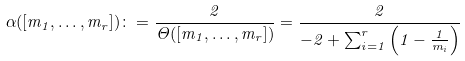Convert formula to latex. <formula><loc_0><loc_0><loc_500><loc_500>\alpha ( [ m _ { 1 } , \dots , m _ { r } ] ) \colon = \frac { 2 } { \Theta ( [ m _ { 1 } , \dots , m _ { r } ] ) } = \frac { 2 } { - 2 + \sum _ { i = 1 } ^ { r } \left ( 1 - \frac { 1 } { m _ { i } } \right ) }</formula> 